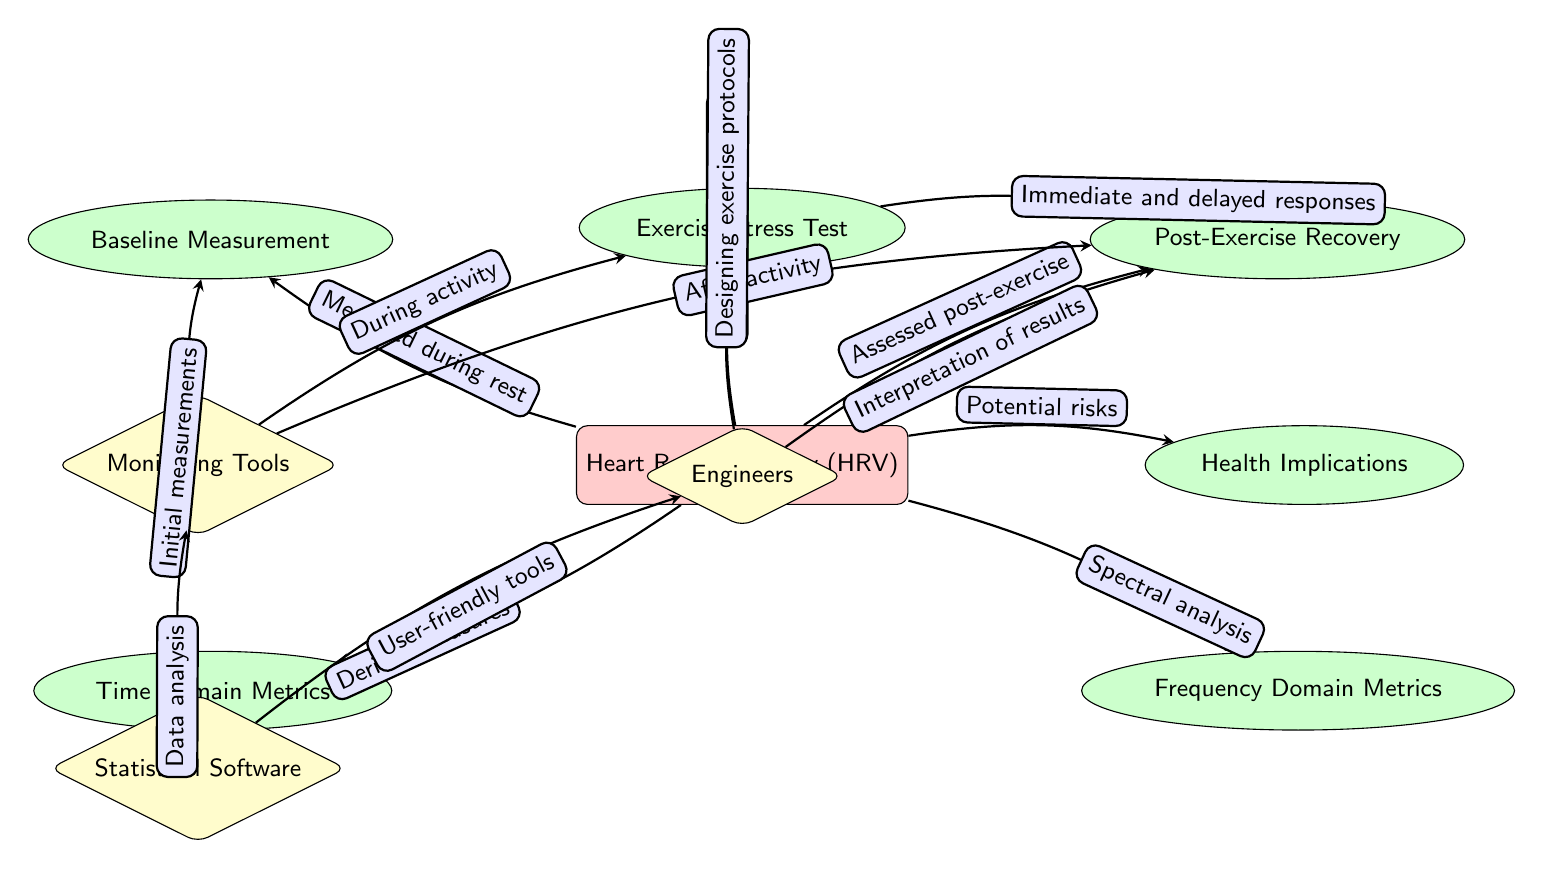What is the main measurement discussed in the diagram? The diagram prominently features Heart Rate Variability (HRV) as the central measurement, indicated at the center of the diagram.
Answer: Heart Rate Variability (HRV) How many secondary nodes are there? Counting the nodes surrounding the central HRV node, there are six secondary nodes: Baseline Measurement, Exercise Stress Test, Post-Exercise Recovery, Time Domain Metrics, Frequency Domain Metrics, and Health Implications.
Answer: 6 Which testing phase is assessed post-exercise? The diagram indicates that the Post-Exercise Recovery phase is specifically assessed after exercise, as shown by the direction of the arrows leading to that node from HRV.
Answer: Post-Exercise Recovery What type of analysis is used for Frequency Domain Metrics? The diagram specifies that Frequency Domain Metrics are derived from spectral analysis, as indicated by the arrow leading from HRV to this secondary node with the corresponding relationship noted.
Answer: Spectral analysis What do Monitoring Tools provide initial measurements for? The diagram shows that Monitoring Tools are linked to Baseline Measurement, meaning they provide the initial measurements needed before exercise activities.
Answer: Baseline Measurement What role do engineers play in the context of the diagram? The diagram highlights that engineers are involved in designing exercise protocols as well as interpreting the results from the Post-Exercise Recovery phase, demonstrating their crucial role in the entire process.
Answer: Designing exercise protocols, Interpretation of results Which metrics are derived measures? The Time Domain Metrics node is specifically indicated as derived measures in the context of HRV assessment, based on the flow from HRV to this node.
Answer: Time Domain Metrics How are changes from exercise characterized? The diagram states that changes in Heart Rate Variability (HRV) are characterized with exercise through the Exercise Stress Test phase, highlighting an active relationship through the connecting arrow.
Answer: Changes with exercise What does the statistical software provide for engineers? The diagram indicates that statistical software offers user-friendly tools, as shown by the connection pointing towards engineers, facilitating their work in data analysis.
Answer: User-friendly tools 